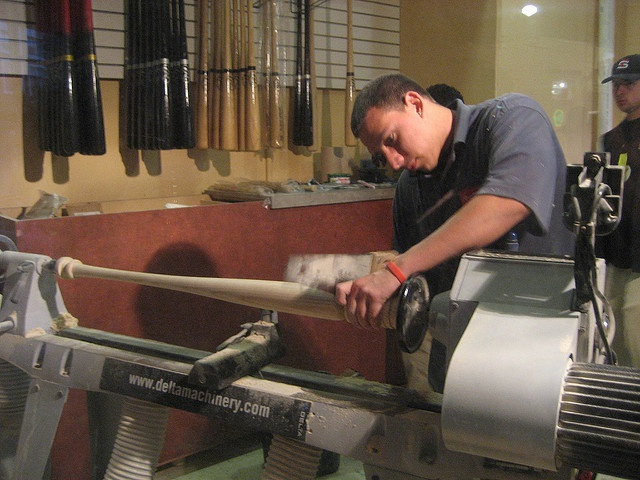Describe the objects in this image and their specific colors. I can see people in gray, black, brown, and maroon tones, people in gray, black, and maroon tones, baseball bat in gray, maroon, and tan tones, and baseball bat in gray, black, darkgray, and lightgray tones in this image. 